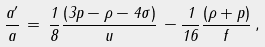Convert formula to latex. <formula><loc_0><loc_0><loc_500><loc_500>\frac { a ^ { \prime } } { a } \, = \, \frac { 1 } { 8 } \frac { ( 3 p - \rho - 4 \sigma ) } { u } \, - \frac { 1 } { 1 6 } \frac { ( \rho + p ) } { f } \, ,</formula> 